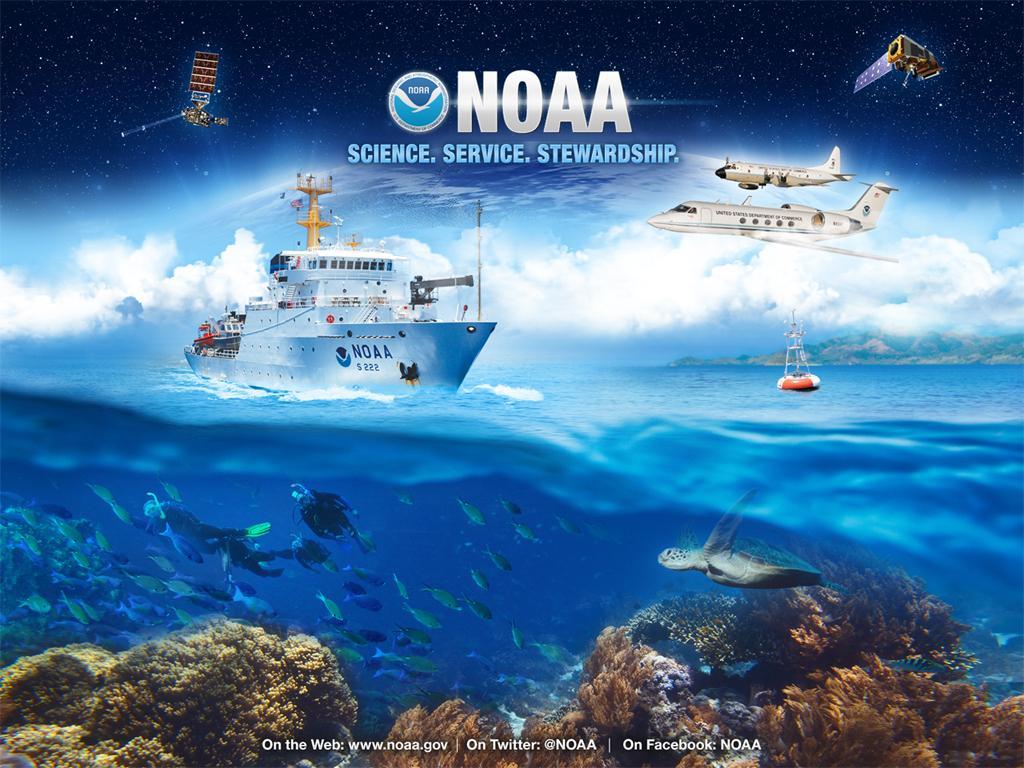How would you summarize this image in a sentence or two? In this picture I can see a poster, there are ships on the water, there are hills, there are airplanes flying in the sky, there are satellites in the galaxy, there are fishes, corals, there are three persons and a turtle in the water, there are words and a logo on the poster. 